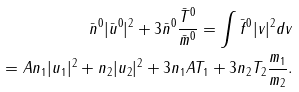Convert formula to latex. <formula><loc_0><loc_0><loc_500><loc_500>\bar { n } ^ { 0 } | \bar { u } ^ { 0 } | ^ { 2 } + 3 \bar { n } ^ { 0 } \frac { \bar { T } ^ { 0 } } { \bar { m } ^ { 0 } } = \int \bar { f } ^ { 0 } | v | ^ { 2 } d v \\ = A n _ { 1 } | u _ { 1 } | ^ { 2 } + n _ { 2 } | u _ { 2 } | ^ { 2 } + 3 n _ { 1 } A T _ { 1 } + 3 n _ { 2 } T _ { 2 } \frac { m _ { 1 } } { m _ { 2 } } .</formula> 